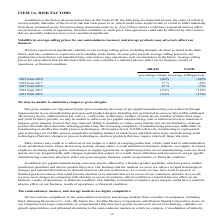According to Micron Technology's financial document, What was the effect on the company when the average selling prices for the products decline faster than the costs? a material adverse effect on our business, results of operations, or financial condition.. The document states: "ucts that decline faster than our costs could have a material adverse effect on our business, results of operations, or financial condition...." Also, What is the percentage change in average selling price of DRAM from 2016 to 2017? According to the financial document, 19%. The relevant text states: "2019 from 2018 (30)% (44)%..." Also, 	 What is the percentage change in average selling price of NAND from 2018 to 2019? According to the financial document, (44)%. The relevant text states: "2019 from 2018 (30)% (44)%..." Also, can you calculate: What is the difference between percentage change in average selling prices of DRAM and NAND in 2019 from 2018? Based on the calculation: 44 - 30 , the result is 14 (percentage). This is based on the information: "2019 from 2018 (30)% (44)% 2019 from 2018 (30)% (44)%..." The key data points involved are: 30, 44. Also, can you calculate: What is the ratio of percentage change in average selling prices of DRAM in '2017 from 2016' to '2018 from 2017'? Based on the calculation: 19/37 , the result is 0.51. This is based on the information: "2018 from 2017 37 % (8)% 2019 from 2018 (30)% (44)%..." The key data points involved are: 19, 37. Additionally, What is the highest percentage increase in average selling prices of DRAM from 2015 to 2019? According to the financial document, 37 (percentage). The relevant text states: "2018 from 2017 37 % (8)%..." 